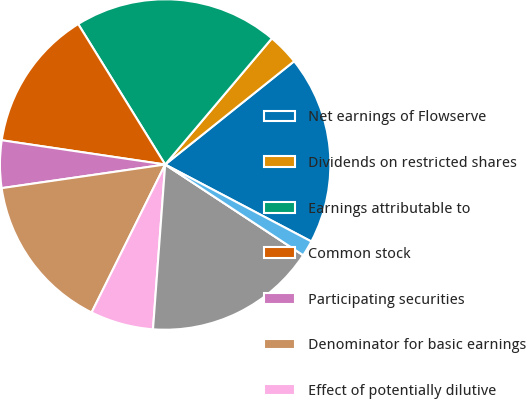Convert chart to OTSL. <chart><loc_0><loc_0><loc_500><loc_500><pie_chart><fcel>Net earnings of Flowserve<fcel>Dividends on restricted shares<fcel>Earnings attributable to<fcel>Common stock<fcel>Participating securities<fcel>Denominator for basic earnings<fcel>Effect of potentially dilutive<fcel>Denominator for diluted<fcel>Basic<fcel>Diluted<nl><fcel>18.46%<fcel>3.08%<fcel>20.0%<fcel>13.83%<fcel>4.63%<fcel>15.37%<fcel>6.17%<fcel>16.92%<fcel>0.0%<fcel>1.54%<nl></chart> 